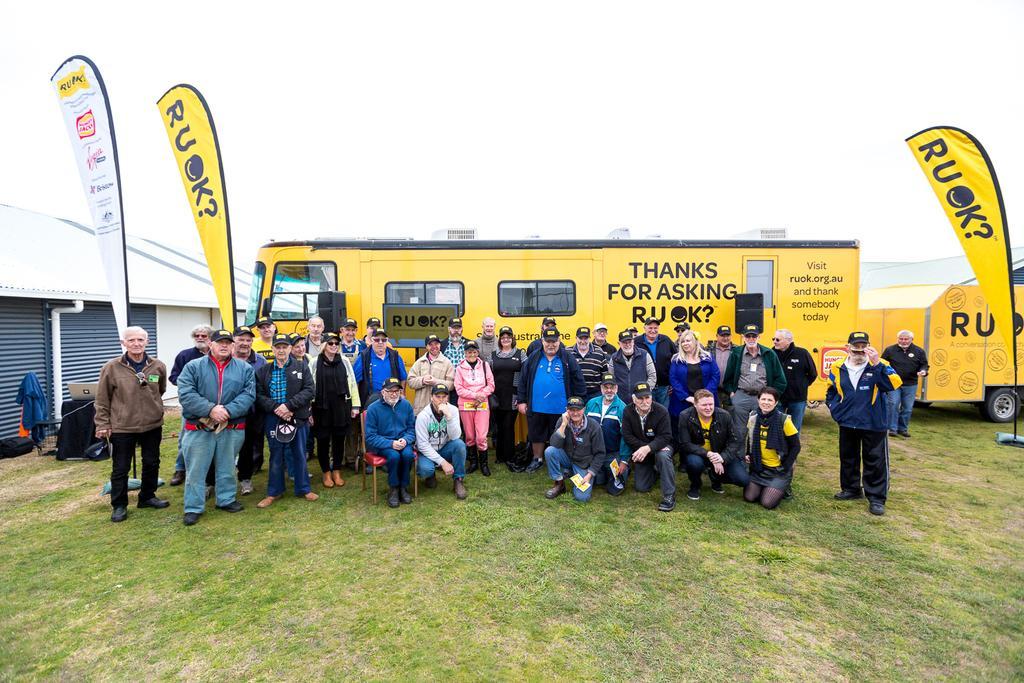In one or two sentences, can you explain what this image depicts? In the center of the image we can see many persons on the grass. On the right side we can see vehicle and flag. On the left side of the image we can see flags and shed. In the background we can see bus and sky. 